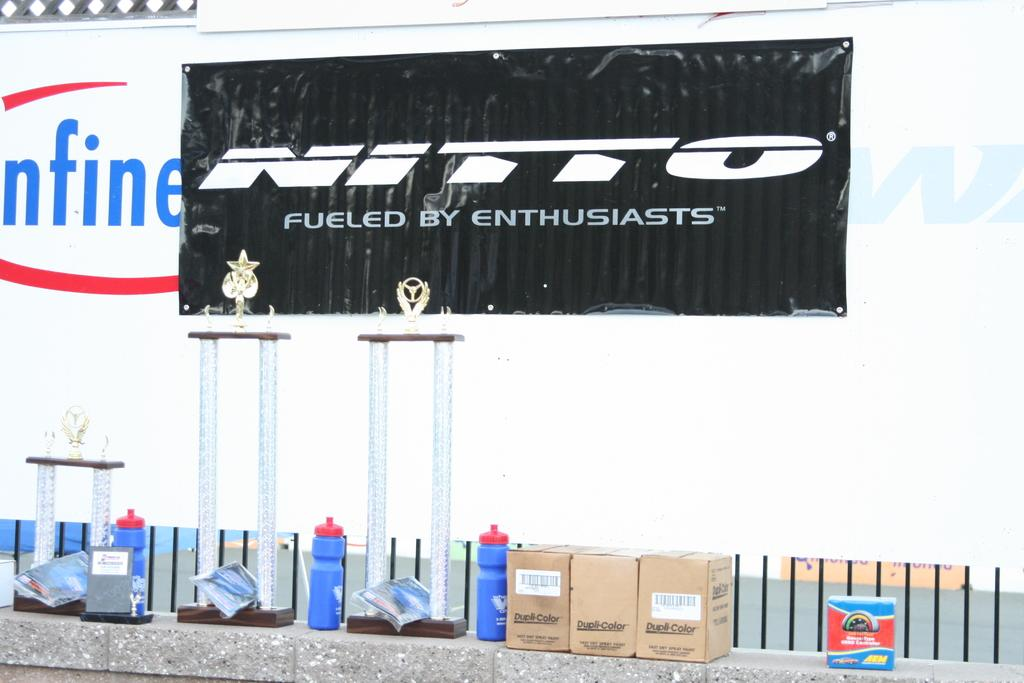<image>
Summarize the visual content of the image. An automotive product is marketed as fueled by enthusiasts. 